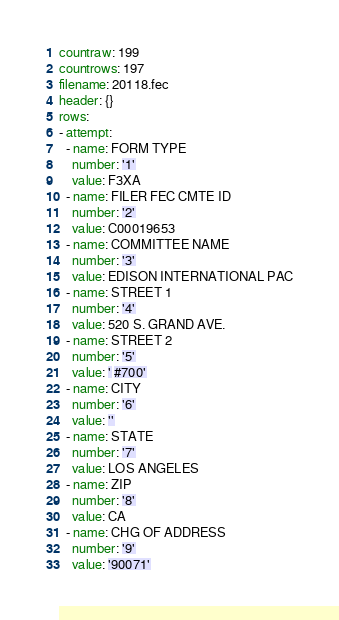<code> <loc_0><loc_0><loc_500><loc_500><_YAML_>countraw: 199
countrows: 197
filename: 20118.fec
header: {}
rows:
- attempt:
  - name: FORM TYPE
    number: '1'
    value: F3XA
  - name: FILER FEC CMTE ID
    number: '2'
    value: C00019653
  - name: COMMITTEE NAME
    number: '3'
    value: EDISON INTERNATIONAL PAC
  - name: STREET 1
    number: '4'
    value: 520 S. GRAND AVE.
  - name: STREET 2
    number: '5'
    value: ' #700'
  - name: CITY
    number: '6'
    value: ''
  - name: STATE
    number: '7'
    value: LOS ANGELES
  - name: ZIP
    number: '8'
    value: CA
  - name: CHG OF ADDRESS
    number: '9'
    value: '90071'</code> 